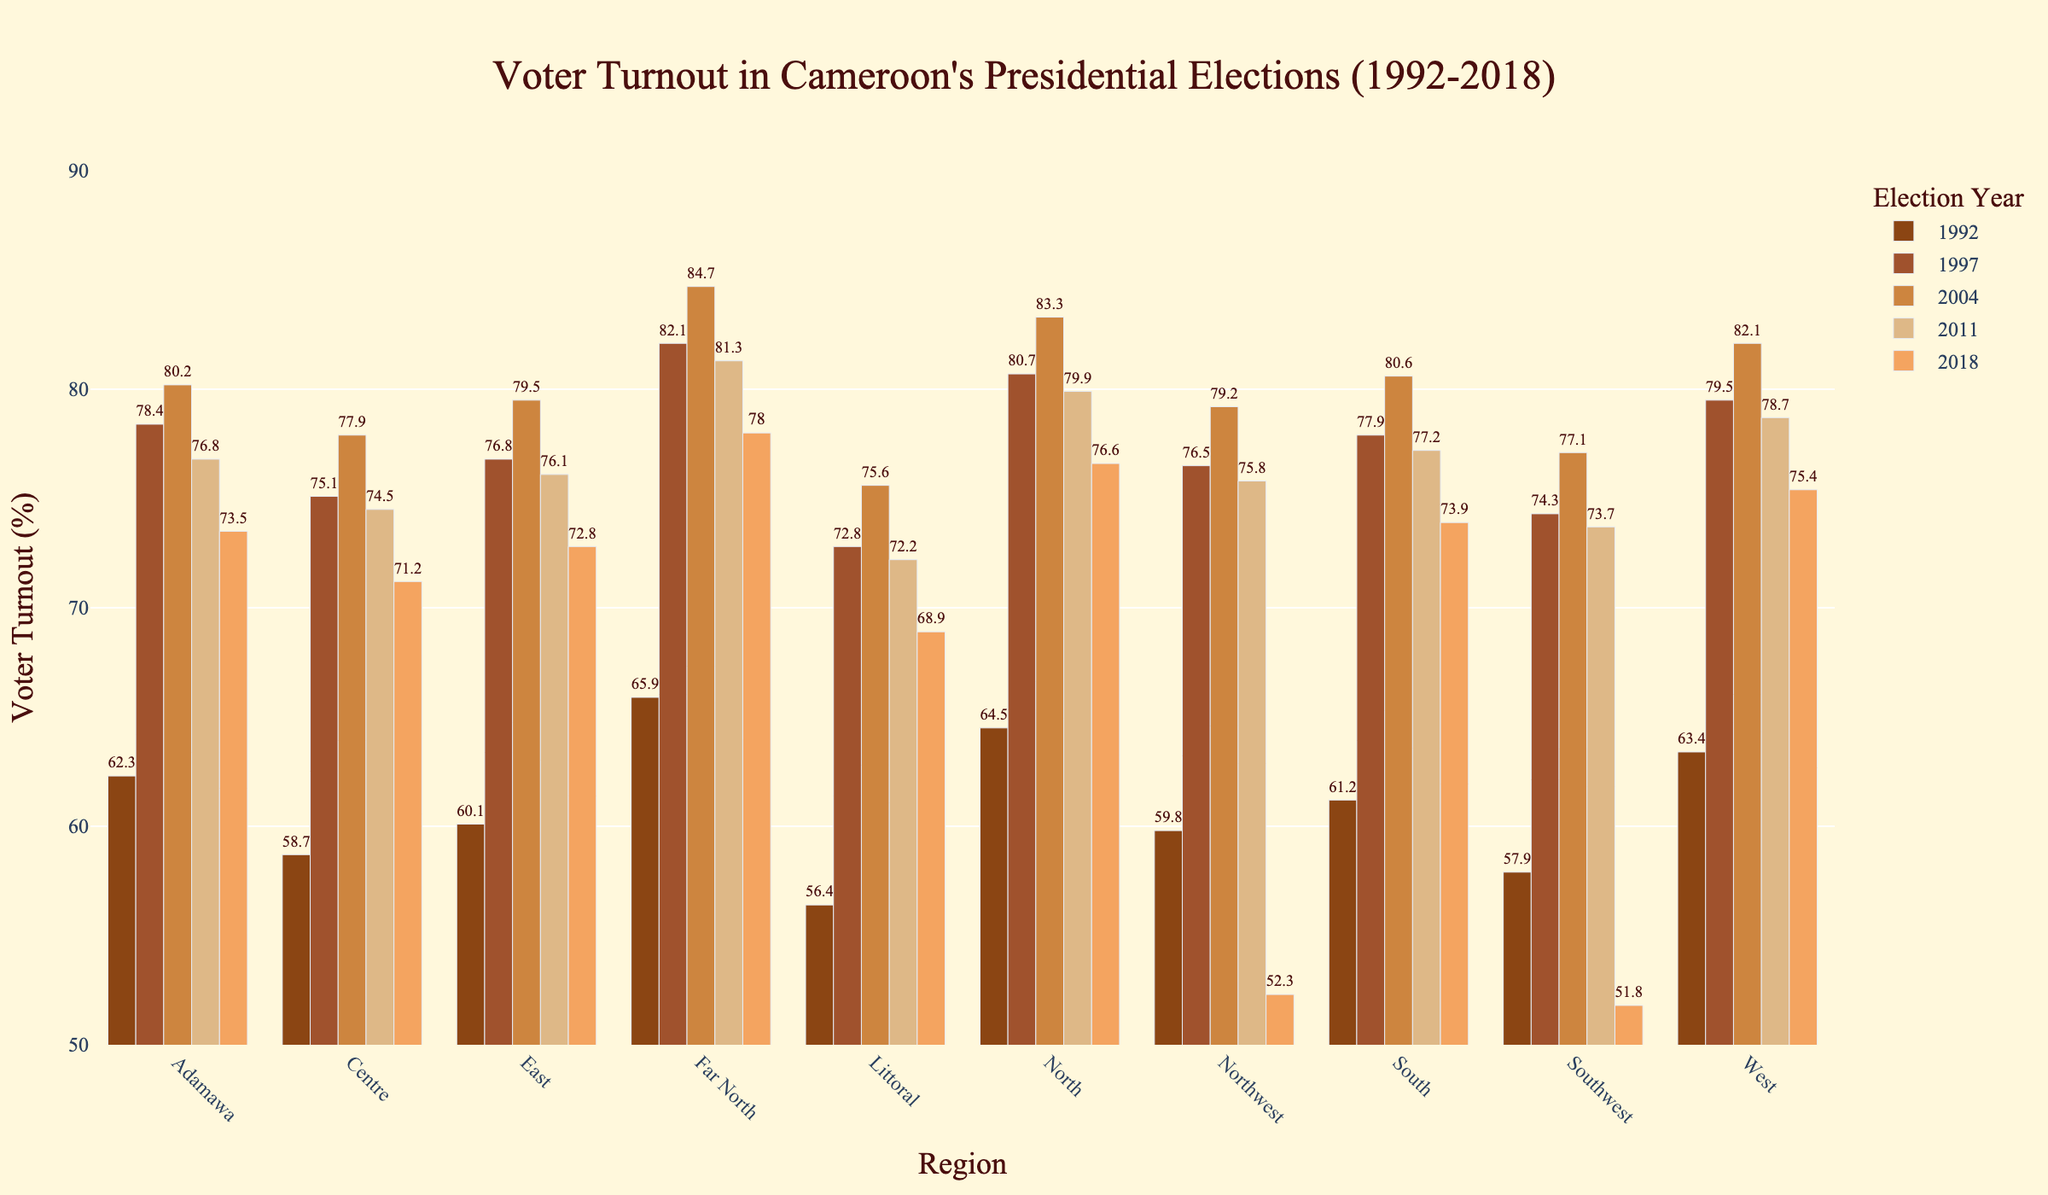Which region had the highest voter turnout in 1992? To find the highest voter turnout in 1992, we compare the bars for 1992 across all regions. The Far North region shows the highest voter turnout.
Answer: Far North What is the difference in voter turnout between the North and Southwest regions in 2018? To find the difference, we subtract the voter turnout of Southwest (51.8%) from that of the North (76.6%) for the year 2018. This calculation gives us 76.6 - 51.8.
Answer: 24.8% How did the voter turnout in the Centre region change from 1997 to 2004? We look at the bars for the Centre region for the years 1997 and 2004 and observe the difference. The turnout increased from 75.1% to 77.9%. By subtracting 75.1 from 77.9, we see an increase of 2.8%.
Answer: Increased by 2.8% Which year had the lowest turnout in the Northwest region, and what was that percentage? By comparing the bars for the Northwest region across all years, we find that 2018 had the lowest turnout. The height of the bar in 2018 represents 52.3%.
Answer: 2018, 52.3% What is the average voter turnout for the South region across all years? To find the average, we add the voter turnout percentages for the South region across all years and then divide by the number of years. The sum is 61.2 + 77.9 + 80.6 + 77.2 + 73.9 = 370.8. We then divide 370.8 by 5.
Answer: 74.2% Which two regions had the most similar voter turnouts in 2011? To determine this, we compare the height of the bars for 2011 across all regions. The West (78.7%) and South (77.2%) regions have the most similar voter turnouts. The absolute difference is 1.5%.
Answer: West and South How many regions had a voter turnout higher than 80% in 2004? By looking at the bars for 2004, we count the number of regions where the voter turnout exceeds 80%. These regions are Far North (84.7%), North (83.3%), and West (82.1%). Therefore, there are three regions.
Answer: 3 regions Which region saw the largest decline in voter turnout from 2011 to 2018? To determine the largest decline, we compare the voter turnouts between 2011 and 2018 for all regions. By calculating the differences, we find that the Northwest region declined from 75.8% to 52.3%, a drop of 23.5%.
Answer: Northwest In which year did the East region see its highest voter turnout? By examining the bars for the East region, we see the highest voter turnout was in 2004, with a percentage of 79.5%.
Answer: 2004 